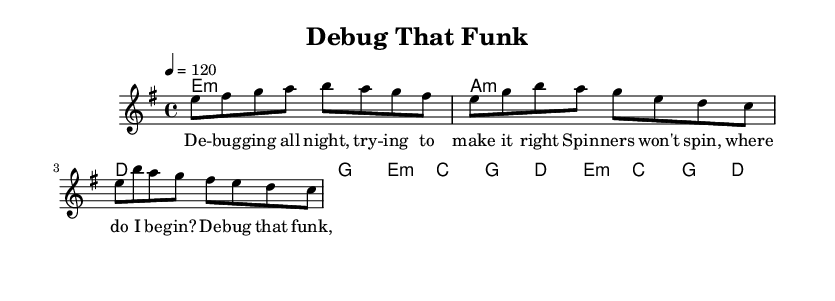What is the key signature of this music? The key signature is indicated at the beginning of the staff and shows two sharps, which corresponds to E minor.
Answer: E minor What is the time signature of this music? The time signature is found in the beginning section of the sheet music, represented by the 4/4 notation. This indicates that there are four beats in a measure.
Answer: 4/4 What is the tempo marking in this piece? The tempo marking is indicated with a number, specifying the beats per minute. In this case, it is written as "4 = 120," which means there are 120 beats per minute.
Answer: 120 How many measures are in the verse section of the music? To find the number of measures, one must count the distinct segments separated by vertical lines in the verse. The verse consists of four measures.
Answer: 4 What type of chord is played in the first measure of the harmonies? The first measure has a minor chord indicated with "e1:m," which means it is an E minor chord played for one whole note duration.
Answer: E minor Why does the chorus repeat a similar melodic line to the verse? The purpose of repetition in funk music often includes reinforcing the theme or message, creating a catchy hook, and maintaining high energy. Here the chorus echoes the hook from the verse in a rhythmic and melodic fashion.
Answer: Catchy hook How does the melody in the chorus differ from that in the verse? The melody in the chorus generally has a more uplifting and energetic feel compared to the verse, characterized by higher notes and rhythmic emphasis that aligns with the thematic progression of overcoming challenges.
Answer: Uplifting and energetic 